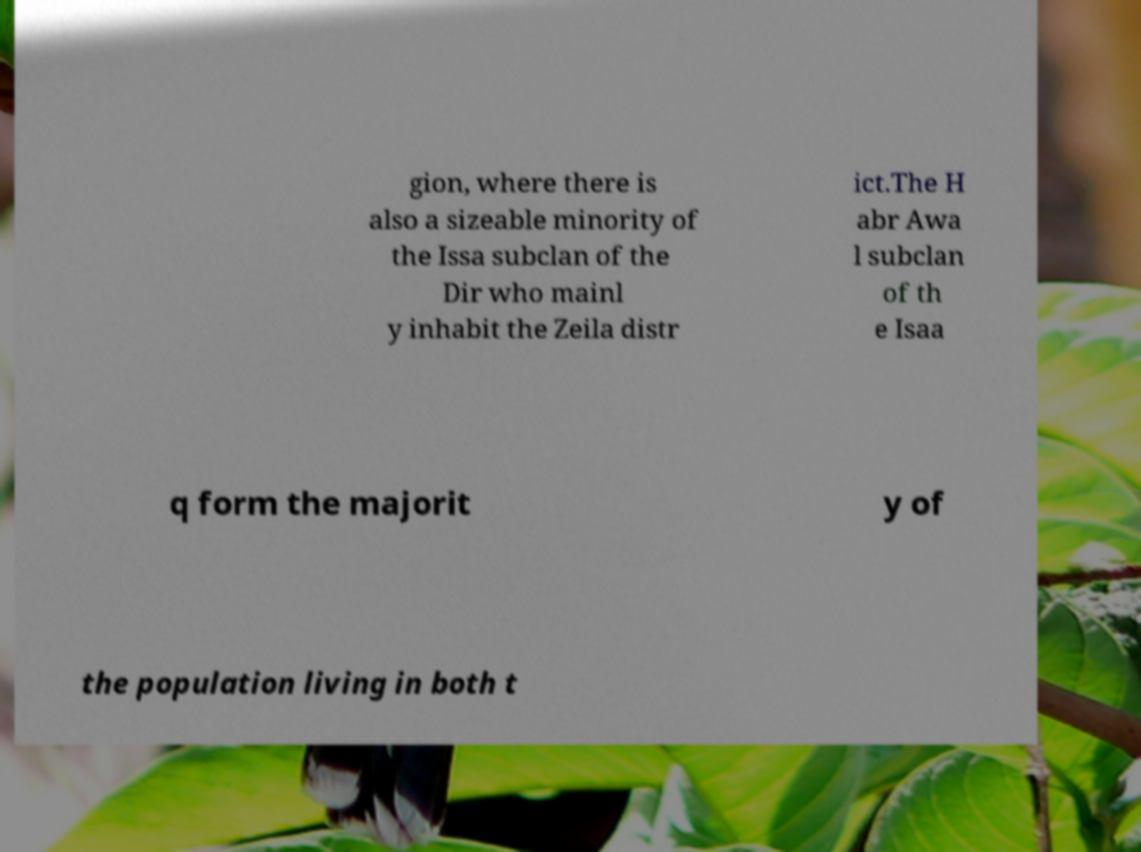There's text embedded in this image that I need extracted. Can you transcribe it verbatim? gion, where there is also a sizeable minority of the Issa subclan of the Dir who mainl y inhabit the Zeila distr ict.The H abr Awa l subclan of th e Isaa q form the majorit y of the population living in both t 